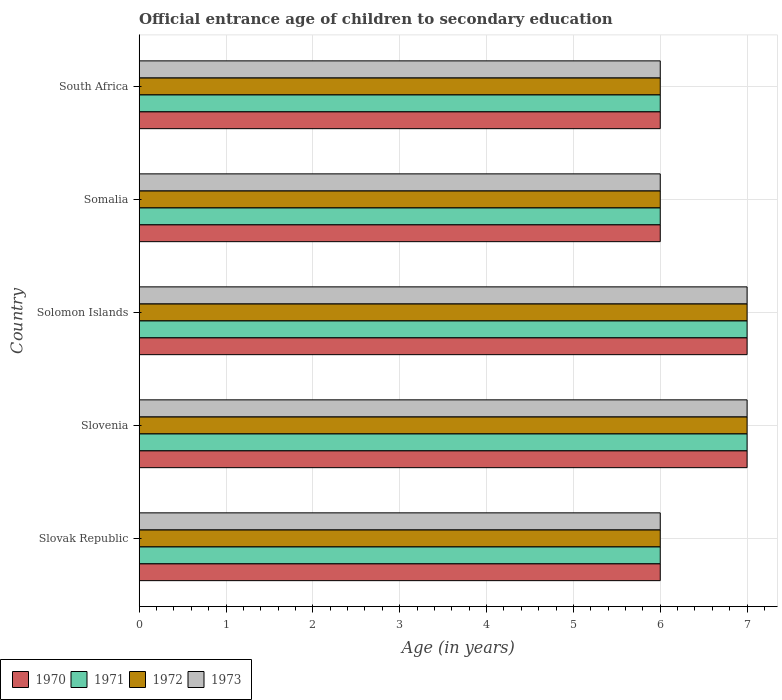How many different coloured bars are there?
Your answer should be very brief. 4. How many groups of bars are there?
Provide a succinct answer. 5. Are the number of bars per tick equal to the number of legend labels?
Make the answer very short. Yes. How many bars are there on the 5th tick from the top?
Your answer should be compact. 4. How many bars are there on the 4th tick from the bottom?
Make the answer very short. 4. What is the label of the 2nd group of bars from the top?
Your answer should be compact. Somalia. In how many cases, is the number of bars for a given country not equal to the number of legend labels?
Provide a succinct answer. 0. Across all countries, what is the maximum secondary school starting age of children in 1971?
Make the answer very short. 7. Across all countries, what is the minimum secondary school starting age of children in 1973?
Your answer should be compact. 6. In which country was the secondary school starting age of children in 1970 maximum?
Your answer should be compact. Slovenia. In which country was the secondary school starting age of children in 1971 minimum?
Give a very brief answer. Slovak Republic. What is the difference between the secondary school starting age of children in 1971 in South Africa and the secondary school starting age of children in 1972 in Slovak Republic?
Make the answer very short. 0. In how many countries, is the secondary school starting age of children in 1972 greater than 6.2 years?
Your answer should be very brief. 2. What is the ratio of the secondary school starting age of children in 1972 in Somalia to that in South Africa?
Give a very brief answer. 1. Is the difference between the secondary school starting age of children in 1970 in Slovenia and South Africa greater than the difference between the secondary school starting age of children in 1972 in Slovenia and South Africa?
Provide a short and direct response. No. What is the difference between the highest and the second highest secondary school starting age of children in 1970?
Provide a succinct answer. 0. What is the difference between the highest and the lowest secondary school starting age of children in 1972?
Give a very brief answer. 1. What does the 1st bar from the top in South Africa represents?
Offer a very short reply. 1973. Is it the case that in every country, the sum of the secondary school starting age of children in 1971 and secondary school starting age of children in 1970 is greater than the secondary school starting age of children in 1973?
Keep it short and to the point. Yes. How many bars are there?
Provide a succinct answer. 20. What is the difference between two consecutive major ticks on the X-axis?
Your answer should be compact. 1. Does the graph contain grids?
Keep it short and to the point. Yes. How many legend labels are there?
Ensure brevity in your answer.  4. How are the legend labels stacked?
Provide a succinct answer. Horizontal. What is the title of the graph?
Keep it short and to the point. Official entrance age of children to secondary education. Does "2004" appear as one of the legend labels in the graph?
Ensure brevity in your answer.  No. What is the label or title of the X-axis?
Offer a terse response. Age (in years). What is the Age (in years) in 1971 in Slovak Republic?
Offer a very short reply. 6. What is the Age (in years) in 1972 in Slovak Republic?
Offer a terse response. 6. What is the Age (in years) of 1970 in Slovenia?
Your answer should be compact. 7. What is the Age (in years) in 1971 in Slovenia?
Provide a succinct answer. 7. What is the Age (in years) of 1972 in Slovenia?
Your answer should be very brief. 7. What is the Age (in years) of 1971 in Solomon Islands?
Provide a succinct answer. 7. What is the Age (in years) of 1972 in Solomon Islands?
Make the answer very short. 7. What is the Age (in years) in 1973 in Solomon Islands?
Keep it short and to the point. 7. What is the Age (in years) in 1970 in Somalia?
Provide a short and direct response. 6. What is the Age (in years) of 1973 in Somalia?
Offer a terse response. 6. What is the Age (in years) of 1972 in South Africa?
Make the answer very short. 6. Across all countries, what is the maximum Age (in years) in 1972?
Your answer should be very brief. 7. Across all countries, what is the maximum Age (in years) in 1973?
Make the answer very short. 7. Across all countries, what is the minimum Age (in years) of 1971?
Give a very brief answer. 6. Across all countries, what is the minimum Age (in years) in 1972?
Keep it short and to the point. 6. Across all countries, what is the minimum Age (in years) of 1973?
Your answer should be very brief. 6. What is the total Age (in years) of 1971 in the graph?
Ensure brevity in your answer.  32. What is the total Age (in years) of 1973 in the graph?
Your answer should be very brief. 32. What is the difference between the Age (in years) of 1970 in Slovak Republic and that in Slovenia?
Your answer should be very brief. -1. What is the difference between the Age (in years) of 1972 in Slovak Republic and that in Slovenia?
Make the answer very short. -1. What is the difference between the Age (in years) of 1973 in Slovak Republic and that in Slovenia?
Provide a short and direct response. -1. What is the difference between the Age (in years) of 1970 in Slovak Republic and that in Solomon Islands?
Your response must be concise. -1. What is the difference between the Age (in years) of 1971 in Slovak Republic and that in Solomon Islands?
Make the answer very short. -1. What is the difference between the Age (in years) of 1972 in Slovak Republic and that in Solomon Islands?
Keep it short and to the point. -1. What is the difference between the Age (in years) of 1972 in Slovak Republic and that in Somalia?
Your answer should be compact. 0. What is the difference between the Age (in years) in 1973 in Slovak Republic and that in Somalia?
Make the answer very short. 0. What is the difference between the Age (in years) of 1973 in Slovak Republic and that in South Africa?
Offer a terse response. 0. What is the difference between the Age (in years) of 1970 in Slovenia and that in Solomon Islands?
Your response must be concise. 0. What is the difference between the Age (in years) of 1971 in Slovenia and that in Solomon Islands?
Your answer should be compact. 0. What is the difference between the Age (in years) of 1972 in Slovenia and that in Solomon Islands?
Offer a very short reply. 0. What is the difference between the Age (in years) of 1970 in Slovenia and that in Somalia?
Your response must be concise. 1. What is the difference between the Age (in years) of 1973 in Slovenia and that in Somalia?
Provide a succinct answer. 1. What is the difference between the Age (in years) in 1972 in Slovenia and that in South Africa?
Provide a short and direct response. 1. What is the difference between the Age (in years) of 1973 in Slovenia and that in South Africa?
Ensure brevity in your answer.  1. What is the difference between the Age (in years) in 1970 in Solomon Islands and that in Somalia?
Offer a very short reply. 1. What is the difference between the Age (in years) in 1971 in Solomon Islands and that in Somalia?
Make the answer very short. 1. What is the difference between the Age (in years) of 1973 in Solomon Islands and that in Somalia?
Provide a short and direct response. 1. What is the difference between the Age (in years) in 1970 in Solomon Islands and that in South Africa?
Your answer should be very brief. 1. What is the difference between the Age (in years) of 1973 in Solomon Islands and that in South Africa?
Your answer should be compact. 1. What is the difference between the Age (in years) of 1970 in Somalia and that in South Africa?
Keep it short and to the point. 0. What is the difference between the Age (in years) of 1971 in Somalia and that in South Africa?
Your answer should be compact. 0. What is the difference between the Age (in years) of 1970 in Slovak Republic and the Age (in years) of 1971 in Slovenia?
Provide a succinct answer. -1. What is the difference between the Age (in years) in 1970 in Slovak Republic and the Age (in years) in 1972 in Slovenia?
Give a very brief answer. -1. What is the difference between the Age (in years) of 1970 in Slovak Republic and the Age (in years) of 1973 in Slovenia?
Offer a terse response. -1. What is the difference between the Age (in years) of 1971 in Slovak Republic and the Age (in years) of 1973 in Slovenia?
Your answer should be compact. -1. What is the difference between the Age (in years) of 1970 in Slovak Republic and the Age (in years) of 1972 in Solomon Islands?
Provide a succinct answer. -1. What is the difference between the Age (in years) of 1971 in Slovak Republic and the Age (in years) of 1972 in Solomon Islands?
Give a very brief answer. -1. What is the difference between the Age (in years) in 1971 in Slovak Republic and the Age (in years) in 1973 in Solomon Islands?
Ensure brevity in your answer.  -1. What is the difference between the Age (in years) in 1970 in Slovak Republic and the Age (in years) in 1973 in Somalia?
Make the answer very short. 0. What is the difference between the Age (in years) in 1972 in Slovak Republic and the Age (in years) in 1973 in Somalia?
Keep it short and to the point. 0. What is the difference between the Age (in years) of 1971 in Slovak Republic and the Age (in years) of 1972 in South Africa?
Make the answer very short. 0. What is the difference between the Age (in years) of 1971 in Slovak Republic and the Age (in years) of 1973 in South Africa?
Provide a short and direct response. 0. What is the difference between the Age (in years) of 1972 in Slovak Republic and the Age (in years) of 1973 in South Africa?
Your answer should be compact. 0. What is the difference between the Age (in years) in 1970 in Slovenia and the Age (in years) in 1973 in Solomon Islands?
Your answer should be very brief. 0. What is the difference between the Age (in years) in 1971 in Slovenia and the Age (in years) in 1972 in Solomon Islands?
Keep it short and to the point. 0. What is the difference between the Age (in years) in 1972 in Slovenia and the Age (in years) in 1973 in Solomon Islands?
Offer a terse response. 0. What is the difference between the Age (in years) of 1971 in Slovenia and the Age (in years) of 1972 in Somalia?
Your response must be concise. 1. What is the difference between the Age (in years) of 1971 in Slovenia and the Age (in years) of 1973 in Somalia?
Ensure brevity in your answer.  1. What is the difference between the Age (in years) in 1972 in Slovenia and the Age (in years) in 1973 in Somalia?
Offer a terse response. 1. What is the difference between the Age (in years) in 1972 in Slovenia and the Age (in years) in 1973 in South Africa?
Offer a terse response. 1. What is the difference between the Age (in years) of 1970 in Solomon Islands and the Age (in years) of 1973 in Somalia?
Ensure brevity in your answer.  1. What is the difference between the Age (in years) of 1971 in Solomon Islands and the Age (in years) of 1972 in Somalia?
Keep it short and to the point. 1. What is the difference between the Age (in years) in 1972 in Solomon Islands and the Age (in years) in 1973 in Somalia?
Make the answer very short. 1. What is the difference between the Age (in years) in 1970 in Solomon Islands and the Age (in years) in 1971 in South Africa?
Keep it short and to the point. 1. What is the difference between the Age (in years) of 1971 in Solomon Islands and the Age (in years) of 1972 in South Africa?
Offer a very short reply. 1. What is the difference between the Age (in years) of 1972 in Solomon Islands and the Age (in years) of 1973 in South Africa?
Offer a terse response. 1. What is the difference between the Age (in years) of 1970 in Somalia and the Age (in years) of 1972 in South Africa?
Ensure brevity in your answer.  0. What is the difference between the Age (in years) of 1971 in Somalia and the Age (in years) of 1972 in South Africa?
Your answer should be compact. 0. What is the difference between the Age (in years) in 1971 in Somalia and the Age (in years) in 1973 in South Africa?
Keep it short and to the point. 0. What is the average Age (in years) of 1970 per country?
Your answer should be compact. 6.4. What is the average Age (in years) of 1972 per country?
Your response must be concise. 6.4. What is the average Age (in years) in 1973 per country?
Offer a very short reply. 6.4. What is the difference between the Age (in years) in 1970 and Age (in years) in 1971 in Slovak Republic?
Your response must be concise. 0. What is the difference between the Age (in years) of 1970 and Age (in years) of 1973 in Slovak Republic?
Keep it short and to the point. 0. What is the difference between the Age (in years) in 1971 and Age (in years) in 1972 in Slovak Republic?
Offer a very short reply. 0. What is the difference between the Age (in years) of 1972 and Age (in years) of 1973 in Slovak Republic?
Offer a very short reply. 0. What is the difference between the Age (in years) of 1971 and Age (in years) of 1972 in Slovenia?
Your response must be concise. 0. What is the difference between the Age (in years) of 1971 and Age (in years) of 1973 in Slovenia?
Your answer should be very brief. 0. What is the difference between the Age (in years) in 1972 and Age (in years) in 1973 in Slovenia?
Ensure brevity in your answer.  0. What is the difference between the Age (in years) of 1971 and Age (in years) of 1972 in Solomon Islands?
Provide a short and direct response. 0. What is the difference between the Age (in years) in 1970 and Age (in years) in 1972 in Somalia?
Offer a very short reply. 0. What is the difference between the Age (in years) of 1971 and Age (in years) of 1973 in Somalia?
Keep it short and to the point. 0. What is the difference between the Age (in years) in 1970 and Age (in years) in 1971 in South Africa?
Offer a very short reply. 0. What is the difference between the Age (in years) of 1970 and Age (in years) of 1972 in South Africa?
Give a very brief answer. 0. What is the difference between the Age (in years) in 1970 and Age (in years) in 1973 in South Africa?
Give a very brief answer. 0. What is the ratio of the Age (in years) in 1970 in Slovak Republic to that in Slovenia?
Provide a short and direct response. 0.86. What is the ratio of the Age (in years) in 1972 in Slovak Republic to that in Slovenia?
Provide a short and direct response. 0.86. What is the ratio of the Age (in years) of 1970 in Slovak Republic to that in Solomon Islands?
Offer a terse response. 0.86. What is the ratio of the Age (in years) of 1970 in Slovak Republic to that in Somalia?
Provide a short and direct response. 1. What is the ratio of the Age (in years) of 1971 in Slovak Republic to that in Somalia?
Provide a short and direct response. 1. What is the ratio of the Age (in years) of 1973 in Slovak Republic to that in Somalia?
Keep it short and to the point. 1. What is the ratio of the Age (in years) in 1972 in Slovak Republic to that in South Africa?
Your answer should be very brief. 1. What is the ratio of the Age (in years) of 1971 in Slovenia to that in Solomon Islands?
Offer a very short reply. 1. What is the ratio of the Age (in years) in 1972 in Slovenia to that in Somalia?
Your answer should be compact. 1.17. What is the ratio of the Age (in years) of 1973 in Slovenia to that in Somalia?
Your response must be concise. 1.17. What is the ratio of the Age (in years) of 1970 in Slovenia to that in South Africa?
Ensure brevity in your answer.  1.17. What is the ratio of the Age (in years) in 1971 in Slovenia to that in South Africa?
Your answer should be compact. 1.17. What is the ratio of the Age (in years) in 1972 in Slovenia to that in South Africa?
Offer a very short reply. 1.17. What is the ratio of the Age (in years) of 1970 in Solomon Islands to that in Somalia?
Your answer should be compact. 1.17. What is the ratio of the Age (in years) of 1971 in Solomon Islands to that in South Africa?
Offer a terse response. 1.17. What is the ratio of the Age (in years) of 1972 in Solomon Islands to that in South Africa?
Offer a very short reply. 1.17. What is the ratio of the Age (in years) of 1973 in Solomon Islands to that in South Africa?
Provide a succinct answer. 1.17. What is the ratio of the Age (in years) in 1971 in Somalia to that in South Africa?
Your answer should be compact. 1. What is the ratio of the Age (in years) of 1972 in Somalia to that in South Africa?
Give a very brief answer. 1. What is the ratio of the Age (in years) in 1973 in Somalia to that in South Africa?
Provide a short and direct response. 1. What is the difference between the highest and the second highest Age (in years) of 1970?
Your response must be concise. 0. What is the difference between the highest and the second highest Age (in years) of 1971?
Provide a short and direct response. 0. What is the difference between the highest and the second highest Age (in years) of 1972?
Keep it short and to the point. 0. What is the difference between the highest and the lowest Age (in years) in 1972?
Offer a terse response. 1. What is the difference between the highest and the lowest Age (in years) of 1973?
Give a very brief answer. 1. 